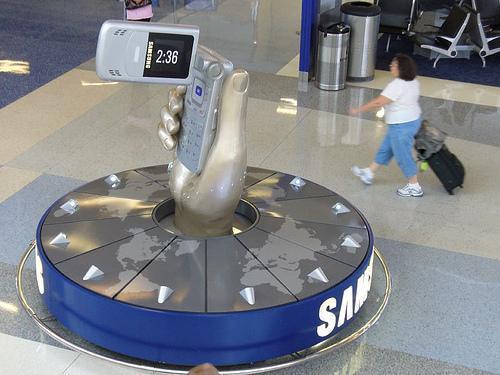How many people carrying the suitcase?
Give a very brief answer. 1. How many garbage cans are visible?
Give a very brief answer. 2. 